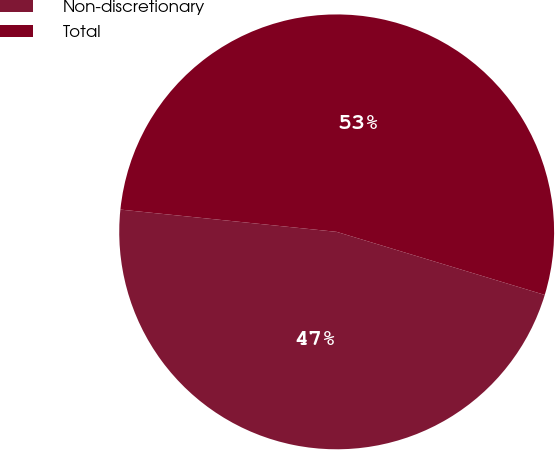Convert chart to OTSL. <chart><loc_0><loc_0><loc_500><loc_500><pie_chart><fcel>Non-discretionary<fcel>Total<nl><fcel>46.95%<fcel>53.05%<nl></chart> 